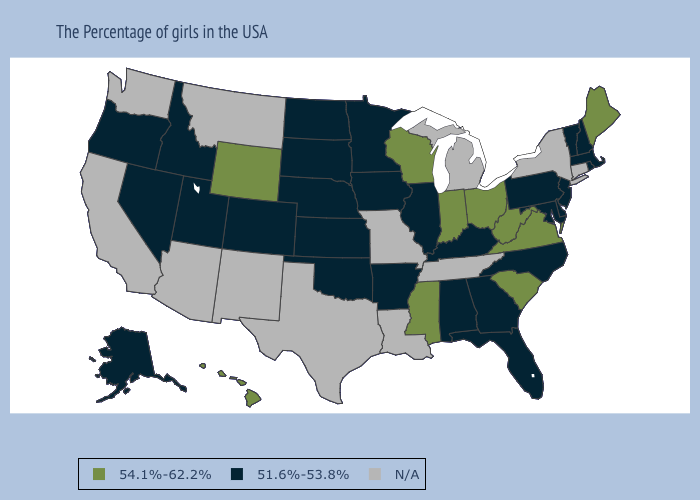What is the highest value in the USA?
Give a very brief answer. 54.1%-62.2%. Does Hawaii have the lowest value in the West?
Give a very brief answer. No. What is the highest value in the Northeast ?
Answer briefly. 54.1%-62.2%. Name the states that have a value in the range 54.1%-62.2%?
Short answer required. Maine, Virginia, South Carolina, West Virginia, Ohio, Indiana, Wisconsin, Mississippi, Wyoming, Hawaii. Which states have the highest value in the USA?
Be succinct. Maine, Virginia, South Carolina, West Virginia, Ohio, Indiana, Wisconsin, Mississippi, Wyoming, Hawaii. What is the lowest value in the South?
Concise answer only. 51.6%-53.8%. What is the lowest value in the MidWest?
Concise answer only. 51.6%-53.8%. Does the first symbol in the legend represent the smallest category?
Give a very brief answer. No. Name the states that have a value in the range N/A?
Quick response, please. Connecticut, New York, Michigan, Tennessee, Louisiana, Missouri, Texas, New Mexico, Montana, Arizona, California, Washington. What is the value of New Jersey?
Quick response, please. 51.6%-53.8%. Among the states that border Alabama , which have the lowest value?
Keep it brief. Florida, Georgia. Name the states that have a value in the range 51.6%-53.8%?
Concise answer only. Massachusetts, Rhode Island, New Hampshire, Vermont, New Jersey, Delaware, Maryland, Pennsylvania, North Carolina, Florida, Georgia, Kentucky, Alabama, Illinois, Arkansas, Minnesota, Iowa, Kansas, Nebraska, Oklahoma, South Dakota, North Dakota, Colorado, Utah, Idaho, Nevada, Oregon, Alaska. How many symbols are there in the legend?
Keep it brief. 3. Does Kentucky have the lowest value in the South?
Write a very short answer. Yes. 